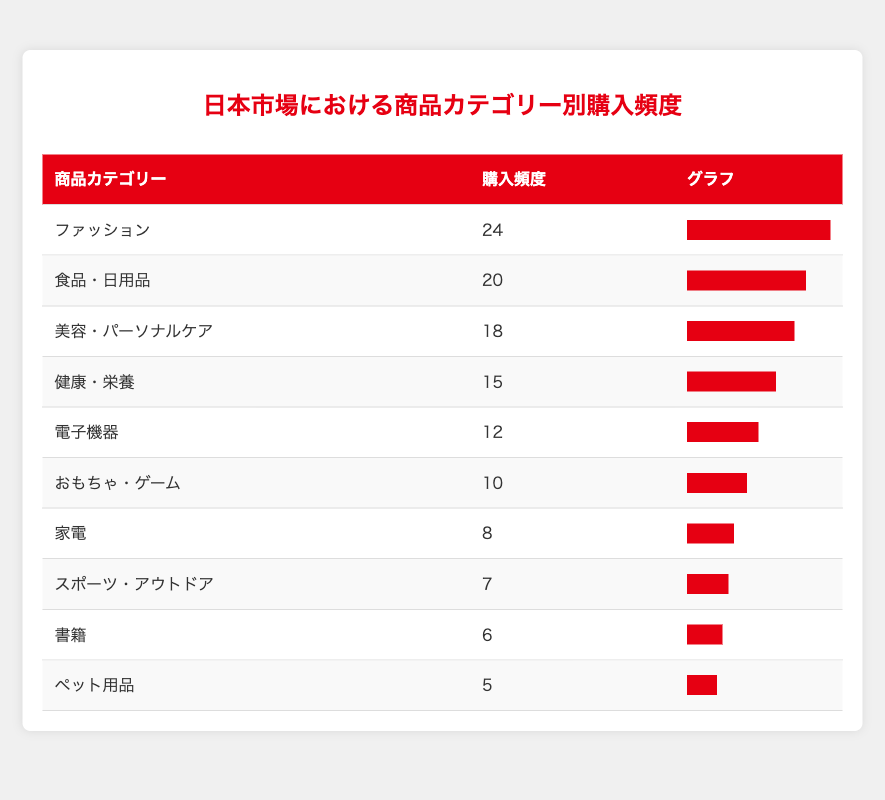What is the product category with the highest purchase frequency? By examining the purchase frequency column, the highest value is found in the Fashion category with a frequency of 24.
Answer: Fashion How many product categories have a purchase frequency of 10 or less? Looking at the purchase frequency values, the categories with 10 or less are Home Appliances (8), Sports and Outdoors (7), Books (6), and Pet Supplies (5). This totals 4 categories.
Answer: 4 What is the difference in purchase frequency between Electronics and Grocery? The purchase frequency for Electronics is 12 and for Grocery it is 20. The difference is calculated as 20 - 12 = 8.
Answer: 8 Is the purchase frequency for Health and Nutrition greater than that for Toys and Games? Health and Nutrition has a purchase frequency of 15 while Toys and Games has a frequency of 10. Since 15 is greater than 10, the answer is yes.
Answer: Yes What is the average purchase frequency across all product categories? Adding all the purchase frequencies: 12 + 24 + 18 + 8 + 15 + 6 + 20 + 7 + 10 + 5 = 125. There are 10 categories, so the average is 125 / 10 = 12.5.
Answer: 12.5 What percentage of the total purchase frequency does the Electronics category represent? The total purchase frequency is 125. Electronics has a frequency of 12. The percentage is calculated as (12 / 125) * 100 = 9.6%.
Answer: 9.6% Which category has a purchase frequency closest to the median of all categories? First, we arrange the purchase frequencies: 5, 6, 7, 8, 10, 12, 15, 18, 20, 24. The median is the average of the 5th and 6th values, which is (10 + 12) / 2 = 11. The category closest to the median is Electronics with 12.
Answer: Electronics Is the purchase frequency of Fashion double that of Pet Supplies? Fashion has a frequency of 24 while Pet Supplies has 5. Doubling Pet Supplies gives us 10, which is less than 24, thus the statement is false.
Answer: No 